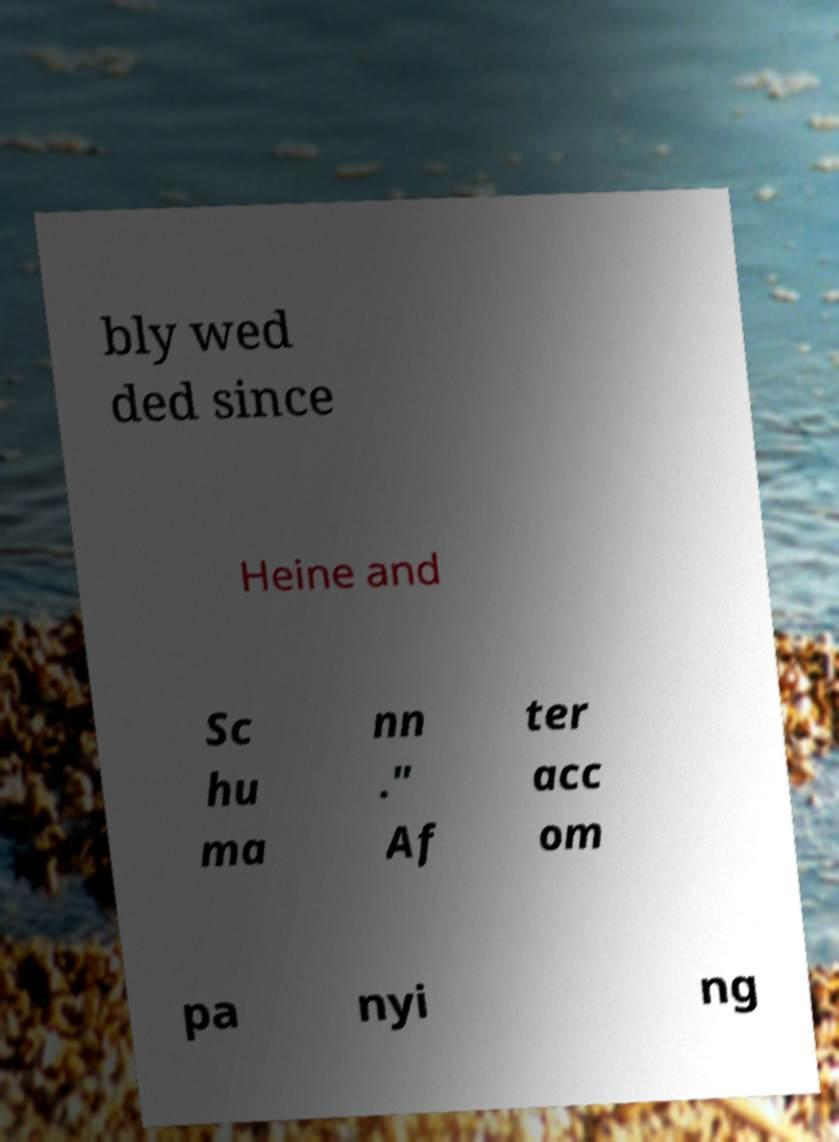What messages or text are displayed in this image? I need them in a readable, typed format. bly wed ded since Heine and Sc hu ma nn ." Af ter acc om pa nyi ng 